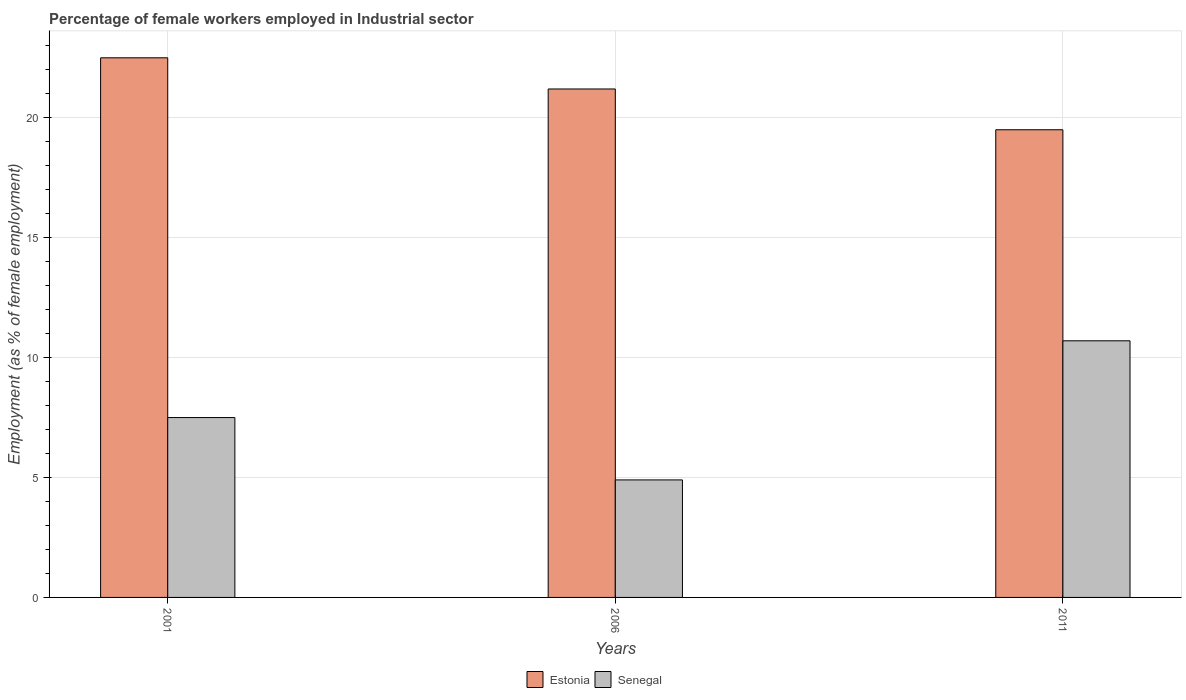Are the number of bars on each tick of the X-axis equal?
Your answer should be very brief. Yes. Across all years, what is the maximum percentage of females employed in Industrial sector in Senegal?
Your answer should be compact. 10.7. Across all years, what is the minimum percentage of females employed in Industrial sector in Senegal?
Your answer should be very brief. 4.9. In which year was the percentage of females employed in Industrial sector in Estonia maximum?
Your answer should be compact. 2001. In which year was the percentage of females employed in Industrial sector in Estonia minimum?
Offer a terse response. 2011. What is the total percentage of females employed in Industrial sector in Senegal in the graph?
Your response must be concise. 23.1. What is the difference between the percentage of females employed in Industrial sector in Estonia in 2006 and that in 2011?
Your answer should be compact. 1.7. What is the difference between the percentage of females employed in Industrial sector in Senegal in 2001 and the percentage of females employed in Industrial sector in Estonia in 2006?
Provide a succinct answer. -13.7. What is the average percentage of females employed in Industrial sector in Estonia per year?
Offer a terse response. 21.07. What is the ratio of the percentage of females employed in Industrial sector in Estonia in 2001 to that in 2006?
Your response must be concise. 1.06. Is the percentage of females employed in Industrial sector in Senegal in 2006 less than that in 2011?
Provide a succinct answer. Yes. Is the difference between the percentage of females employed in Industrial sector in Senegal in 2001 and 2011 greater than the difference between the percentage of females employed in Industrial sector in Estonia in 2001 and 2011?
Give a very brief answer. No. What is the difference between the highest and the second highest percentage of females employed in Industrial sector in Estonia?
Give a very brief answer. 1.3. What is the difference between the highest and the lowest percentage of females employed in Industrial sector in Senegal?
Keep it short and to the point. 5.8. In how many years, is the percentage of females employed in Industrial sector in Senegal greater than the average percentage of females employed in Industrial sector in Senegal taken over all years?
Your answer should be very brief. 1. What does the 1st bar from the left in 2001 represents?
Make the answer very short. Estonia. What does the 1st bar from the right in 2006 represents?
Your answer should be very brief. Senegal. How many years are there in the graph?
Ensure brevity in your answer.  3. What is the difference between two consecutive major ticks on the Y-axis?
Keep it short and to the point. 5. Does the graph contain any zero values?
Provide a short and direct response. No. Does the graph contain grids?
Provide a short and direct response. Yes. Where does the legend appear in the graph?
Ensure brevity in your answer.  Bottom center. What is the title of the graph?
Your answer should be compact. Percentage of female workers employed in Industrial sector. Does "Kuwait" appear as one of the legend labels in the graph?
Keep it short and to the point. No. What is the label or title of the Y-axis?
Provide a succinct answer. Employment (as % of female employment). What is the Employment (as % of female employment) of Estonia in 2001?
Keep it short and to the point. 22.5. What is the Employment (as % of female employment) of Senegal in 2001?
Give a very brief answer. 7.5. What is the Employment (as % of female employment) in Estonia in 2006?
Provide a short and direct response. 21.2. What is the Employment (as % of female employment) of Senegal in 2006?
Keep it short and to the point. 4.9. What is the Employment (as % of female employment) in Senegal in 2011?
Make the answer very short. 10.7. Across all years, what is the maximum Employment (as % of female employment) of Senegal?
Your answer should be compact. 10.7. Across all years, what is the minimum Employment (as % of female employment) in Senegal?
Offer a terse response. 4.9. What is the total Employment (as % of female employment) in Estonia in the graph?
Offer a very short reply. 63.2. What is the total Employment (as % of female employment) of Senegal in the graph?
Ensure brevity in your answer.  23.1. What is the difference between the Employment (as % of female employment) in Estonia in 2001 and that in 2011?
Offer a terse response. 3. What is the difference between the Employment (as % of female employment) of Estonia in 2006 and that in 2011?
Offer a very short reply. 1.7. What is the difference between the Employment (as % of female employment) in Estonia in 2001 and the Employment (as % of female employment) in Senegal in 2011?
Give a very brief answer. 11.8. What is the difference between the Employment (as % of female employment) of Estonia in 2006 and the Employment (as % of female employment) of Senegal in 2011?
Provide a short and direct response. 10.5. What is the average Employment (as % of female employment) in Estonia per year?
Offer a very short reply. 21.07. In the year 2001, what is the difference between the Employment (as % of female employment) in Estonia and Employment (as % of female employment) in Senegal?
Keep it short and to the point. 15. In the year 2006, what is the difference between the Employment (as % of female employment) of Estonia and Employment (as % of female employment) of Senegal?
Give a very brief answer. 16.3. In the year 2011, what is the difference between the Employment (as % of female employment) in Estonia and Employment (as % of female employment) in Senegal?
Provide a short and direct response. 8.8. What is the ratio of the Employment (as % of female employment) in Estonia in 2001 to that in 2006?
Make the answer very short. 1.06. What is the ratio of the Employment (as % of female employment) of Senegal in 2001 to that in 2006?
Provide a short and direct response. 1.53. What is the ratio of the Employment (as % of female employment) in Estonia in 2001 to that in 2011?
Offer a terse response. 1.15. What is the ratio of the Employment (as % of female employment) in Senegal in 2001 to that in 2011?
Make the answer very short. 0.7. What is the ratio of the Employment (as % of female employment) of Estonia in 2006 to that in 2011?
Keep it short and to the point. 1.09. What is the ratio of the Employment (as % of female employment) in Senegal in 2006 to that in 2011?
Your answer should be very brief. 0.46. What is the difference between the highest and the second highest Employment (as % of female employment) of Estonia?
Your response must be concise. 1.3. 